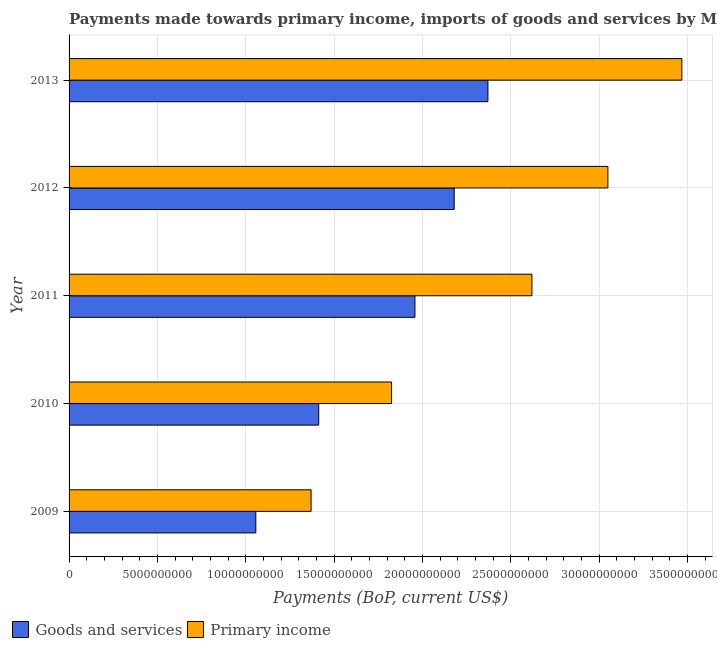How many different coloured bars are there?
Give a very brief answer. 2. How many groups of bars are there?
Keep it short and to the point. 5. How many bars are there on the 4th tick from the bottom?
Offer a very short reply. 2. What is the payments made towards goods and services in 2010?
Keep it short and to the point. 1.41e+1. Across all years, what is the maximum payments made towards goods and services?
Your answer should be compact. 2.37e+1. Across all years, what is the minimum payments made towards goods and services?
Keep it short and to the point. 1.06e+1. In which year was the payments made towards goods and services maximum?
Your answer should be very brief. 2013. What is the total payments made towards primary income in the graph?
Make the answer very short. 1.23e+11. What is the difference between the payments made towards primary income in 2009 and that in 2011?
Your answer should be compact. -1.25e+1. What is the difference between the payments made towards primary income in 2010 and the payments made towards goods and services in 2009?
Provide a short and direct response. 7.68e+09. What is the average payments made towards primary income per year?
Give a very brief answer. 2.47e+1. In the year 2010, what is the difference between the payments made towards goods and services and payments made towards primary income?
Make the answer very short. -4.12e+09. What is the ratio of the payments made towards primary income in 2010 to that in 2013?
Give a very brief answer. 0.53. What is the difference between the highest and the second highest payments made towards goods and services?
Offer a very short reply. 1.91e+09. What is the difference between the highest and the lowest payments made towards primary income?
Make the answer very short. 2.10e+1. In how many years, is the payments made towards goods and services greater than the average payments made towards goods and services taken over all years?
Make the answer very short. 3. What does the 2nd bar from the top in 2013 represents?
Offer a very short reply. Goods and services. What does the 1st bar from the bottom in 2009 represents?
Ensure brevity in your answer.  Goods and services. How many bars are there?
Your answer should be very brief. 10. Are all the bars in the graph horizontal?
Your answer should be very brief. Yes. How many years are there in the graph?
Offer a terse response. 5. Are the values on the major ticks of X-axis written in scientific E-notation?
Give a very brief answer. No. Does the graph contain grids?
Keep it short and to the point. Yes. Where does the legend appear in the graph?
Give a very brief answer. Bottom left. How many legend labels are there?
Offer a terse response. 2. How are the legend labels stacked?
Offer a very short reply. Horizontal. What is the title of the graph?
Make the answer very short. Payments made towards primary income, imports of goods and services by Macao. Does "Under-5(male)" appear as one of the legend labels in the graph?
Offer a very short reply. No. What is the label or title of the X-axis?
Offer a very short reply. Payments (BoP, current US$). What is the label or title of the Y-axis?
Ensure brevity in your answer.  Year. What is the Payments (BoP, current US$) of Goods and services in 2009?
Give a very brief answer. 1.06e+1. What is the Payments (BoP, current US$) of Primary income in 2009?
Your answer should be very brief. 1.37e+1. What is the Payments (BoP, current US$) of Goods and services in 2010?
Offer a terse response. 1.41e+1. What is the Payments (BoP, current US$) in Primary income in 2010?
Your answer should be compact. 1.83e+1. What is the Payments (BoP, current US$) of Goods and services in 2011?
Offer a very short reply. 1.96e+1. What is the Payments (BoP, current US$) of Primary income in 2011?
Your answer should be compact. 2.62e+1. What is the Payments (BoP, current US$) in Goods and services in 2012?
Provide a short and direct response. 2.18e+1. What is the Payments (BoP, current US$) in Primary income in 2012?
Your answer should be very brief. 3.05e+1. What is the Payments (BoP, current US$) in Goods and services in 2013?
Provide a succinct answer. 2.37e+1. What is the Payments (BoP, current US$) of Primary income in 2013?
Your answer should be very brief. 3.47e+1. Across all years, what is the maximum Payments (BoP, current US$) of Goods and services?
Keep it short and to the point. 2.37e+1. Across all years, what is the maximum Payments (BoP, current US$) in Primary income?
Provide a short and direct response. 3.47e+1. Across all years, what is the minimum Payments (BoP, current US$) of Goods and services?
Your answer should be compact. 1.06e+1. Across all years, what is the minimum Payments (BoP, current US$) in Primary income?
Offer a terse response. 1.37e+1. What is the total Payments (BoP, current US$) of Goods and services in the graph?
Provide a short and direct response. 8.98e+1. What is the total Payments (BoP, current US$) in Primary income in the graph?
Keep it short and to the point. 1.23e+11. What is the difference between the Payments (BoP, current US$) of Goods and services in 2009 and that in 2010?
Keep it short and to the point. -3.56e+09. What is the difference between the Payments (BoP, current US$) of Primary income in 2009 and that in 2010?
Keep it short and to the point. -4.56e+09. What is the difference between the Payments (BoP, current US$) of Goods and services in 2009 and that in 2011?
Your response must be concise. -9.01e+09. What is the difference between the Payments (BoP, current US$) in Primary income in 2009 and that in 2011?
Make the answer very short. -1.25e+1. What is the difference between the Payments (BoP, current US$) of Goods and services in 2009 and that in 2012?
Your answer should be compact. -1.12e+1. What is the difference between the Payments (BoP, current US$) in Primary income in 2009 and that in 2012?
Your response must be concise. -1.68e+1. What is the difference between the Payments (BoP, current US$) of Goods and services in 2009 and that in 2013?
Your answer should be very brief. -1.31e+1. What is the difference between the Payments (BoP, current US$) in Primary income in 2009 and that in 2013?
Provide a short and direct response. -2.10e+1. What is the difference between the Payments (BoP, current US$) in Goods and services in 2010 and that in 2011?
Your answer should be very brief. -5.45e+09. What is the difference between the Payments (BoP, current US$) of Primary income in 2010 and that in 2011?
Make the answer very short. -7.95e+09. What is the difference between the Payments (BoP, current US$) of Goods and services in 2010 and that in 2012?
Ensure brevity in your answer.  -7.67e+09. What is the difference between the Payments (BoP, current US$) in Primary income in 2010 and that in 2012?
Provide a short and direct response. -1.22e+1. What is the difference between the Payments (BoP, current US$) of Goods and services in 2010 and that in 2013?
Offer a terse response. -9.58e+09. What is the difference between the Payments (BoP, current US$) of Primary income in 2010 and that in 2013?
Provide a short and direct response. -1.64e+1. What is the difference between the Payments (BoP, current US$) in Goods and services in 2011 and that in 2012?
Give a very brief answer. -2.22e+09. What is the difference between the Payments (BoP, current US$) in Primary income in 2011 and that in 2012?
Give a very brief answer. -4.30e+09. What is the difference between the Payments (BoP, current US$) in Goods and services in 2011 and that in 2013?
Make the answer very short. -4.13e+09. What is the difference between the Payments (BoP, current US$) in Primary income in 2011 and that in 2013?
Offer a terse response. -8.49e+09. What is the difference between the Payments (BoP, current US$) of Goods and services in 2012 and that in 2013?
Your response must be concise. -1.91e+09. What is the difference between the Payments (BoP, current US$) in Primary income in 2012 and that in 2013?
Make the answer very short. -4.19e+09. What is the difference between the Payments (BoP, current US$) of Goods and services in 2009 and the Payments (BoP, current US$) of Primary income in 2010?
Give a very brief answer. -7.68e+09. What is the difference between the Payments (BoP, current US$) in Goods and services in 2009 and the Payments (BoP, current US$) in Primary income in 2011?
Your answer should be compact. -1.56e+1. What is the difference between the Payments (BoP, current US$) of Goods and services in 2009 and the Payments (BoP, current US$) of Primary income in 2012?
Provide a succinct answer. -1.99e+1. What is the difference between the Payments (BoP, current US$) in Goods and services in 2009 and the Payments (BoP, current US$) in Primary income in 2013?
Your answer should be very brief. -2.41e+1. What is the difference between the Payments (BoP, current US$) of Goods and services in 2010 and the Payments (BoP, current US$) of Primary income in 2011?
Keep it short and to the point. -1.21e+1. What is the difference between the Payments (BoP, current US$) of Goods and services in 2010 and the Payments (BoP, current US$) of Primary income in 2012?
Your answer should be compact. -1.64e+1. What is the difference between the Payments (BoP, current US$) in Goods and services in 2010 and the Payments (BoP, current US$) in Primary income in 2013?
Give a very brief answer. -2.06e+1. What is the difference between the Payments (BoP, current US$) of Goods and services in 2011 and the Payments (BoP, current US$) of Primary income in 2012?
Your response must be concise. -1.09e+1. What is the difference between the Payments (BoP, current US$) of Goods and services in 2011 and the Payments (BoP, current US$) of Primary income in 2013?
Provide a short and direct response. -1.51e+1. What is the difference between the Payments (BoP, current US$) in Goods and services in 2012 and the Payments (BoP, current US$) in Primary income in 2013?
Give a very brief answer. -1.29e+1. What is the average Payments (BoP, current US$) of Goods and services per year?
Offer a very short reply. 1.80e+1. What is the average Payments (BoP, current US$) of Primary income per year?
Ensure brevity in your answer.  2.47e+1. In the year 2009, what is the difference between the Payments (BoP, current US$) in Goods and services and Payments (BoP, current US$) in Primary income?
Provide a succinct answer. -3.13e+09. In the year 2010, what is the difference between the Payments (BoP, current US$) in Goods and services and Payments (BoP, current US$) in Primary income?
Give a very brief answer. -4.12e+09. In the year 2011, what is the difference between the Payments (BoP, current US$) of Goods and services and Payments (BoP, current US$) of Primary income?
Your answer should be compact. -6.62e+09. In the year 2012, what is the difference between the Payments (BoP, current US$) in Goods and services and Payments (BoP, current US$) in Primary income?
Keep it short and to the point. -8.70e+09. In the year 2013, what is the difference between the Payments (BoP, current US$) in Goods and services and Payments (BoP, current US$) in Primary income?
Ensure brevity in your answer.  -1.10e+1. What is the ratio of the Payments (BoP, current US$) in Goods and services in 2009 to that in 2010?
Offer a very short reply. 0.75. What is the ratio of the Payments (BoP, current US$) in Primary income in 2009 to that in 2010?
Provide a succinct answer. 0.75. What is the ratio of the Payments (BoP, current US$) of Goods and services in 2009 to that in 2011?
Make the answer very short. 0.54. What is the ratio of the Payments (BoP, current US$) in Primary income in 2009 to that in 2011?
Your response must be concise. 0.52. What is the ratio of the Payments (BoP, current US$) in Goods and services in 2009 to that in 2012?
Provide a short and direct response. 0.48. What is the ratio of the Payments (BoP, current US$) of Primary income in 2009 to that in 2012?
Your answer should be compact. 0.45. What is the ratio of the Payments (BoP, current US$) of Goods and services in 2009 to that in 2013?
Offer a terse response. 0.45. What is the ratio of the Payments (BoP, current US$) in Primary income in 2009 to that in 2013?
Your response must be concise. 0.39. What is the ratio of the Payments (BoP, current US$) of Goods and services in 2010 to that in 2011?
Your response must be concise. 0.72. What is the ratio of the Payments (BoP, current US$) of Primary income in 2010 to that in 2011?
Provide a short and direct response. 0.7. What is the ratio of the Payments (BoP, current US$) of Goods and services in 2010 to that in 2012?
Your answer should be very brief. 0.65. What is the ratio of the Payments (BoP, current US$) in Primary income in 2010 to that in 2012?
Your response must be concise. 0.6. What is the ratio of the Payments (BoP, current US$) of Goods and services in 2010 to that in 2013?
Keep it short and to the point. 0.6. What is the ratio of the Payments (BoP, current US$) in Primary income in 2010 to that in 2013?
Provide a short and direct response. 0.53. What is the ratio of the Payments (BoP, current US$) of Goods and services in 2011 to that in 2012?
Provide a succinct answer. 0.9. What is the ratio of the Payments (BoP, current US$) of Primary income in 2011 to that in 2012?
Provide a short and direct response. 0.86. What is the ratio of the Payments (BoP, current US$) of Goods and services in 2011 to that in 2013?
Provide a short and direct response. 0.83. What is the ratio of the Payments (BoP, current US$) of Primary income in 2011 to that in 2013?
Your answer should be very brief. 0.76. What is the ratio of the Payments (BoP, current US$) in Goods and services in 2012 to that in 2013?
Your response must be concise. 0.92. What is the ratio of the Payments (BoP, current US$) of Primary income in 2012 to that in 2013?
Make the answer very short. 0.88. What is the difference between the highest and the second highest Payments (BoP, current US$) of Goods and services?
Your answer should be very brief. 1.91e+09. What is the difference between the highest and the second highest Payments (BoP, current US$) in Primary income?
Offer a very short reply. 4.19e+09. What is the difference between the highest and the lowest Payments (BoP, current US$) in Goods and services?
Your response must be concise. 1.31e+1. What is the difference between the highest and the lowest Payments (BoP, current US$) of Primary income?
Provide a short and direct response. 2.10e+1. 